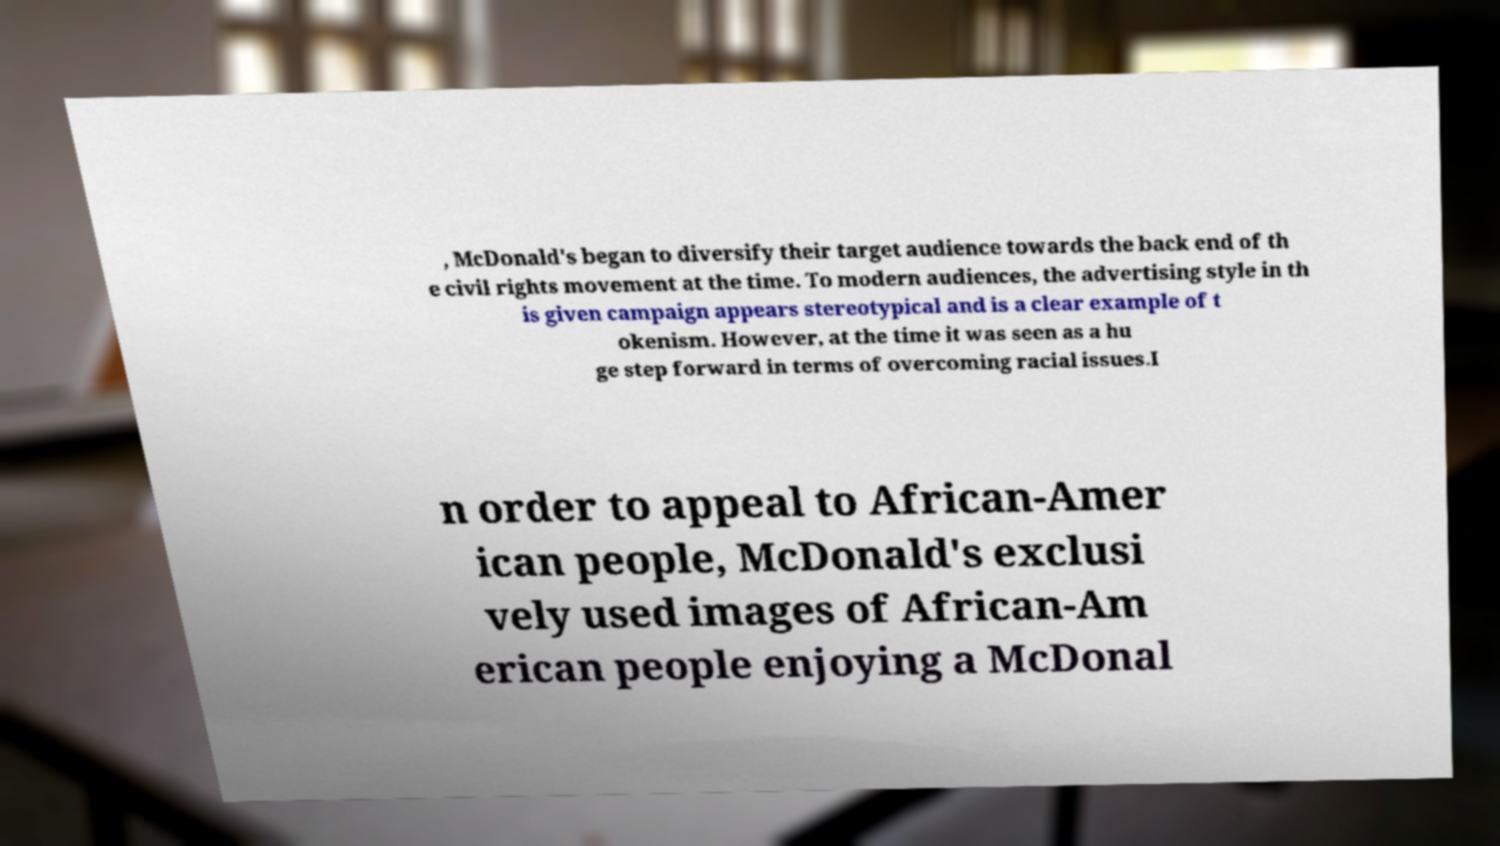Please read and relay the text visible in this image. What does it say? , McDonald's began to diversify their target audience towards the back end of th e civil rights movement at the time. To modern audiences, the advertising style in th is given campaign appears stereotypical and is a clear example of t okenism. However, at the time it was seen as a hu ge step forward in terms of overcoming racial issues.I n order to appeal to African-Amer ican people, McDonald's exclusi vely used images of African-Am erican people enjoying a McDonal 